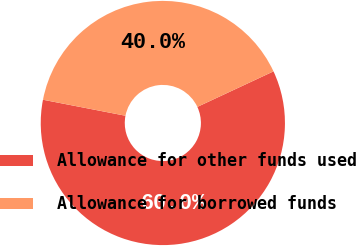Convert chart. <chart><loc_0><loc_0><loc_500><loc_500><pie_chart><fcel>Allowance for other funds used<fcel>Allowance for borrowed funds<nl><fcel>60.0%<fcel>40.0%<nl></chart> 